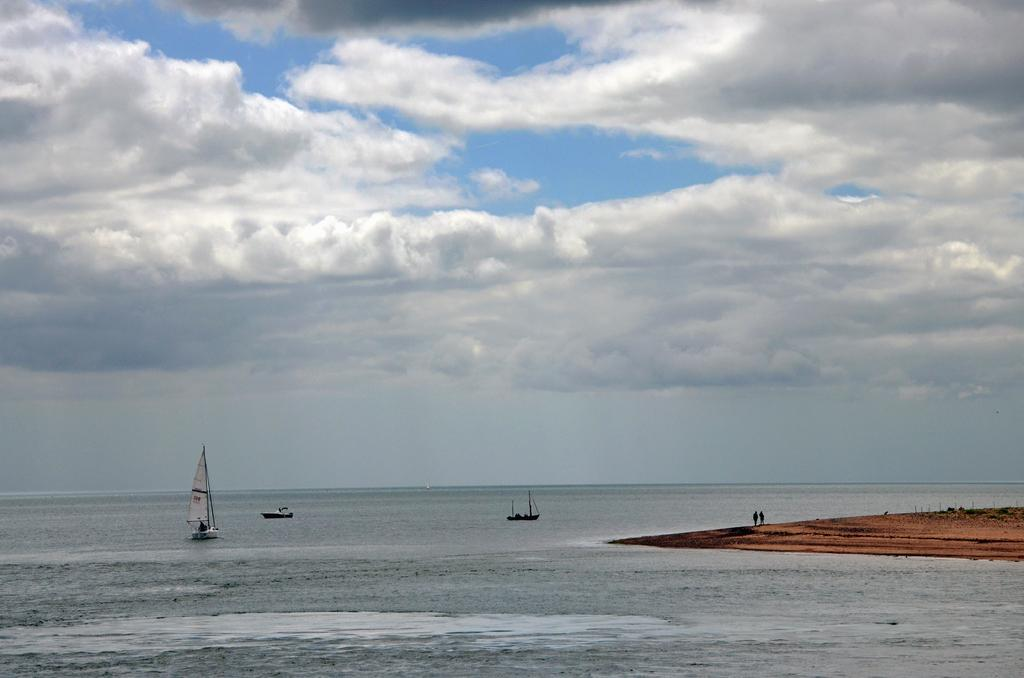What type of vehicles are in the image? There are boats in the image. Where are the boats located? The boats are on the water. What can be seen at the bottom right of the image? There is a ground visible in the bottom right of the image. What is visible in the sky in the image? There are clouds in the sky. How does the image show an increase in dirt levels? The image does not show an increase in dirt levels; it features boats on the water with clouds in the sky. 